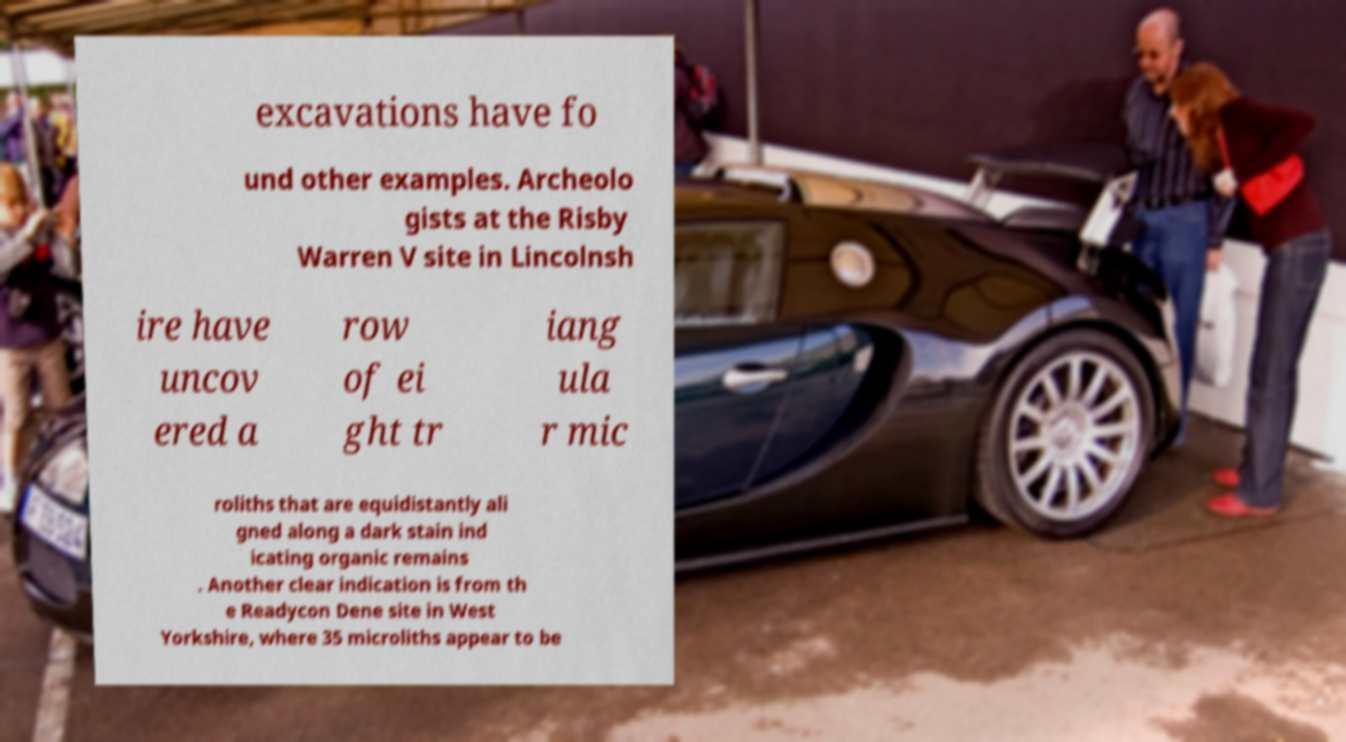There's text embedded in this image that I need extracted. Can you transcribe it verbatim? excavations have fo und other examples. Archeolo gists at the Risby Warren V site in Lincolnsh ire have uncov ered a row of ei ght tr iang ula r mic roliths that are equidistantly ali gned along a dark stain ind icating organic remains . Another clear indication is from th e Readycon Dene site in West Yorkshire, where 35 microliths appear to be 